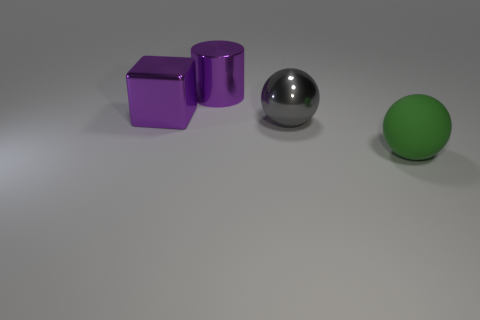Add 4 green spheres. How many objects exist? 8 Subtract all blocks. How many objects are left? 3 Add 4 big green matte objects. How many big green matte objects are left? 5 Add 1 blocks. How many blocks exist? 2 Subtract 0 yellow cubes. How many objects are left? 4 Subtract all small purple shiny cylinders. Subtract all purple objects. How many objects are left? 2 